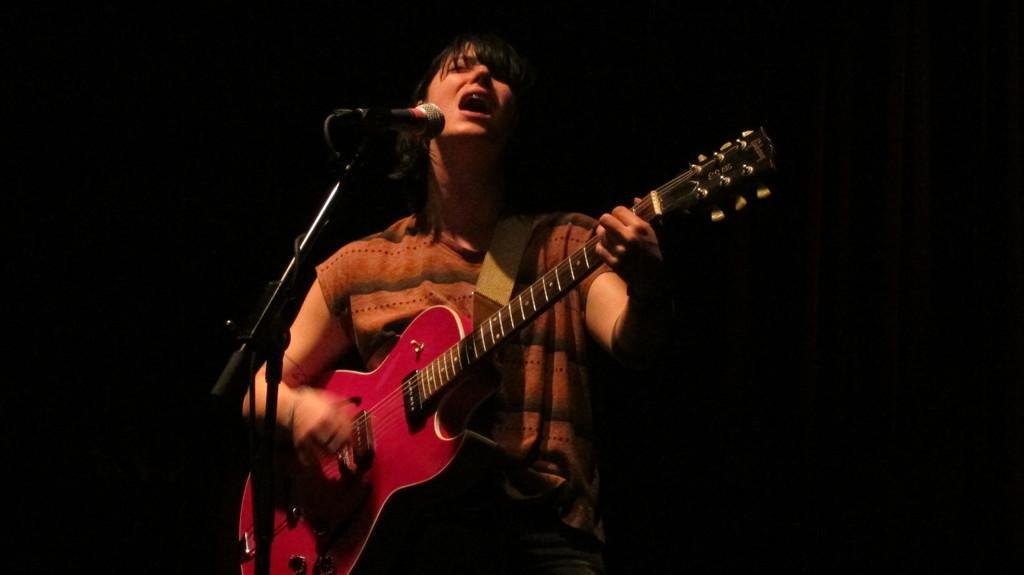Who is the main subject in the image? There is a woman present in the image. What is the woman doing in the image? The woman is playing a guitar in the image. What object is associated with the woman's activity in the image? There is a microphone in the image. How many volleyballs are visible in the image? There are no volleyballs present in the image. What does the woman show respect for in the image? There is no indication of the woman showing respect for anything in the image. 